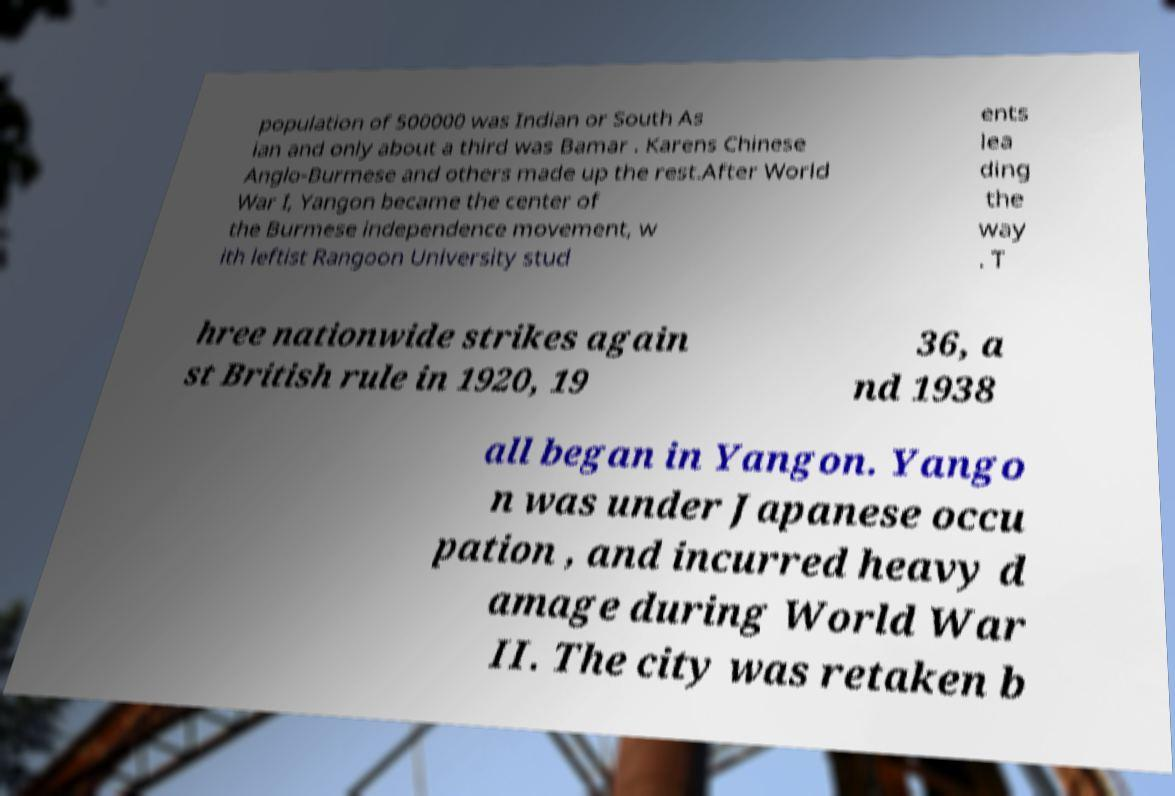For documentation purposes, I need the text within this image transcribed. Could you provide that? population of 500000 was Indian or South As ian and only about a third was Bamar . Karens Chinese Anglo-Burmese and others made up the rest.After World War I, Yangon became the center of the Burmese independence movement, w ith leftist Rangoon University stud ents lea ding the way . T hree nationwide strikes again st British rule in 1920, 19 36, a nd 1938 all began in Yangon. Yango n was under Japanese occu pation , and incurred heavy d amage during World War II. The city was retaken b 